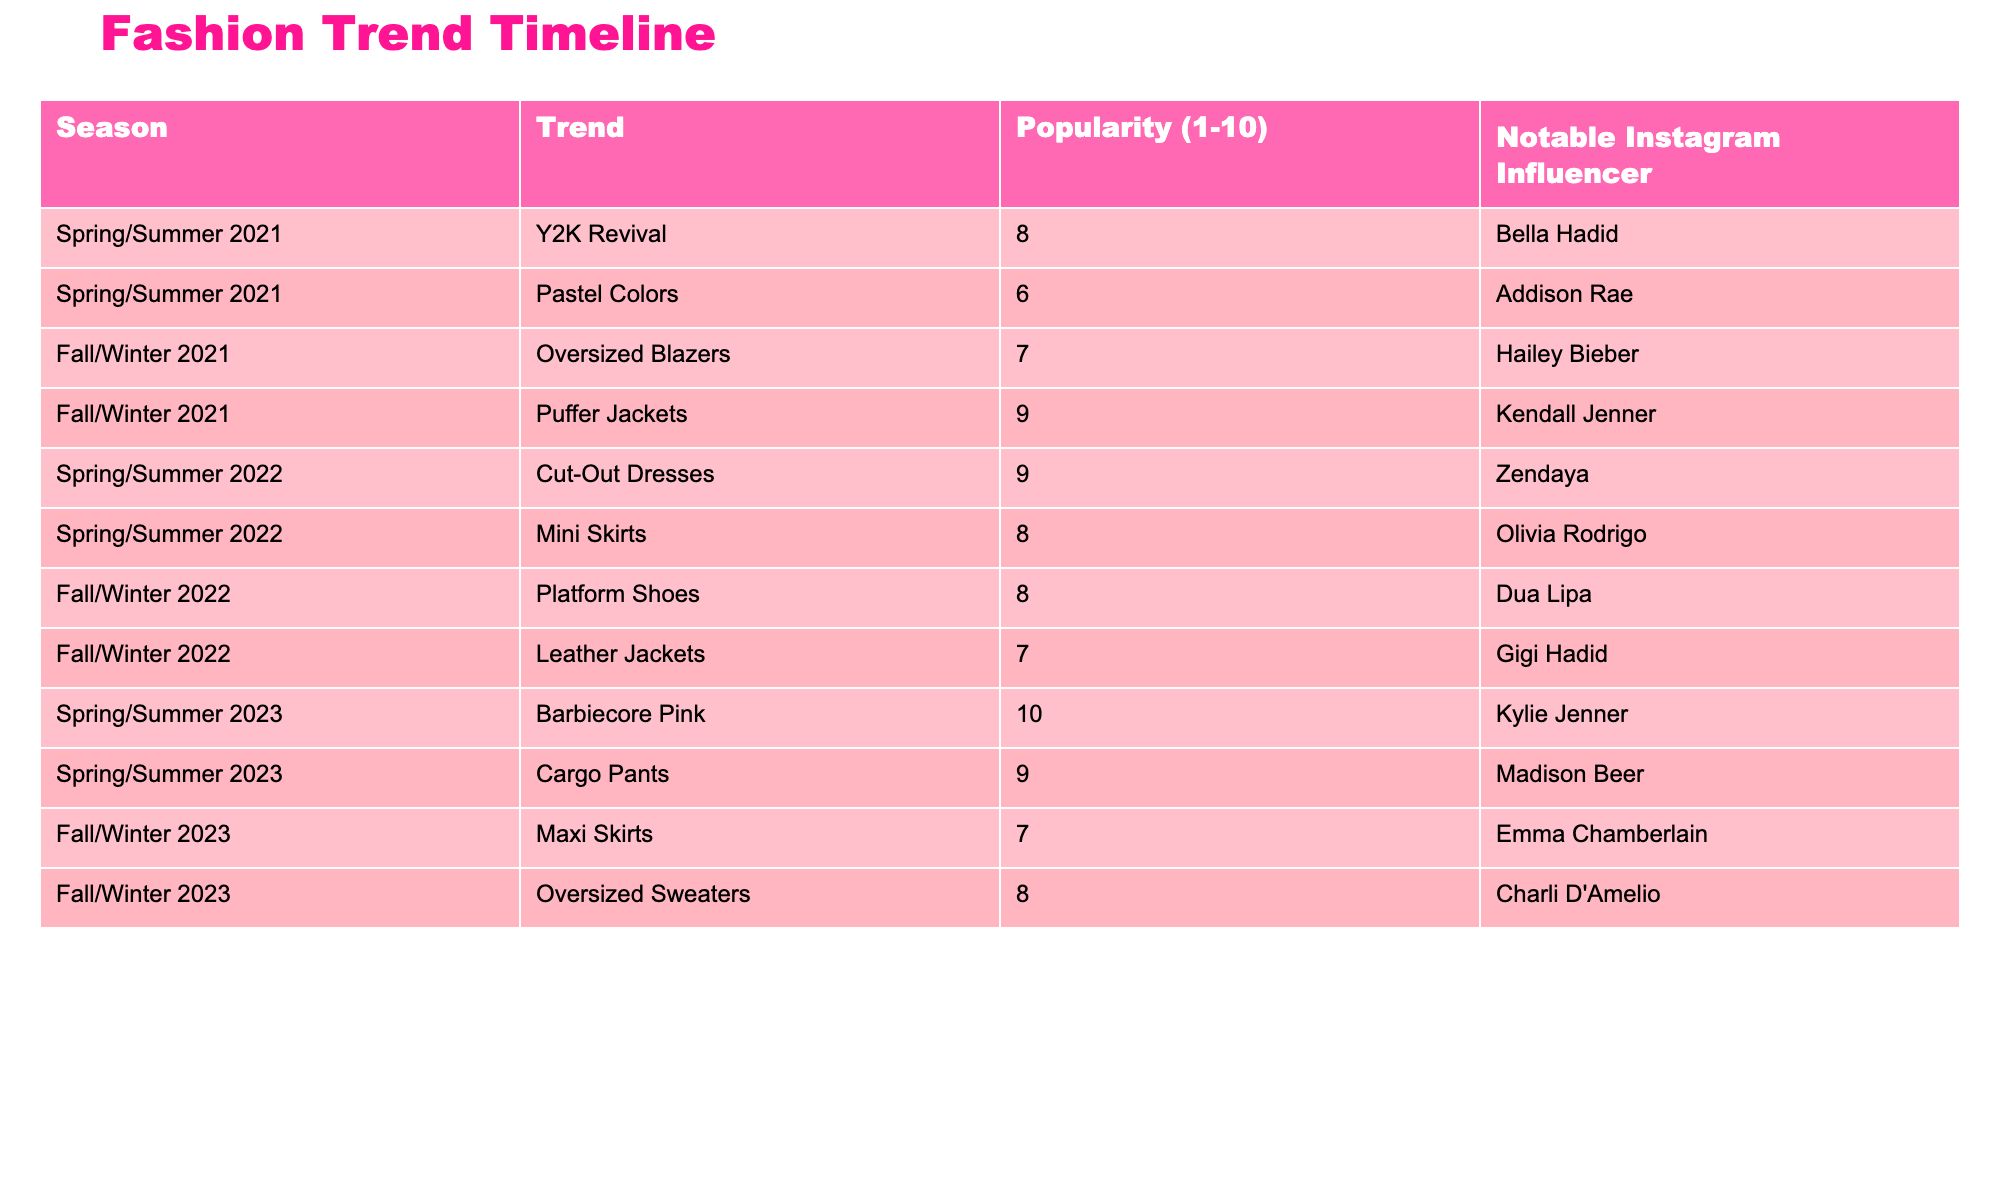What was the most popular fashion trend in Spring/Summer 2023? The table shows that the trend "Barbiecore Pink" in Spring/Summer 2023 has a popularity rating of 10, which is the highest score in the table.
Answer: Barbiecore Pink Who was the notable Instagram influencer for the trend "Oversized Blazers"? The table lists "Oversized Blazers" under Fall/Winter 2021, with Hailey Bieber mentioned as the notable Instagram influencer for that trend.
Answer: Hailey Bieber What is the average popularity score for Fall/Winter trends? The trends for Fall/Winter are "Oversized Blazers" (7), "Puffer Jackets" (9), "Leather Jackets" (7), and "Oversized Sweaters" (8). Adding them gives 7 + 9 + 7 + 8 = 31. There are 4 trends, so the average is 31/4 = 7.75.
Answer: 7.75 Did "Cut-Out Dresses" outperform "Mini Skirts" in popularity? "Cut-Out Dresses" has a popularity score of 9 while "Mini Skirts" only has a score of 8. Since 9 is greater than 8, this means "Cut-Out Dresses" did outperform "Mini Skirts".
Answer: Yes Which season had the lowest popularity trend, and what was the trend? Looking through the table, the trend with the lowest popularity score is "Pastel Colors" with a score of 6 in Spring/Summer 2021.
Answer: Spring/Summer 2021, Pastel Colors What is the total popularity score of all Spring/Summer trends combined? The Spring/Summer trends listed are "Y2K Revival" (8), "Cut-Out Dresses" (9), "Barbiecore Pink" (10), "Pastel Colors" (6), and "Mini Skirts" (8). The scores add up to 8 + 9 + 10 + 6 + 8 = 41.
Answer: 41 Is there any trend with the same popularity score in different seasons? Checking the popularity scores, "Puffer Jackets" and "Platform Shoes" both have a score of 9, but they are from different seasons (Fall/Winter 2021 and Fall/Winter 2022 respectively). Thus, yes, there are trends with the same popularity score.
Answer: Yes What was the trend with the highest popularity score among the trends from Spring/Summer 2022? In Spring/Summer 2022, the trends listed are "Cut-Out Dresses" (9) and "Mini Skirts" (8). The highest score is 9 for "Cut-Out Dresses".
Answer: Cut-Out Dresses 